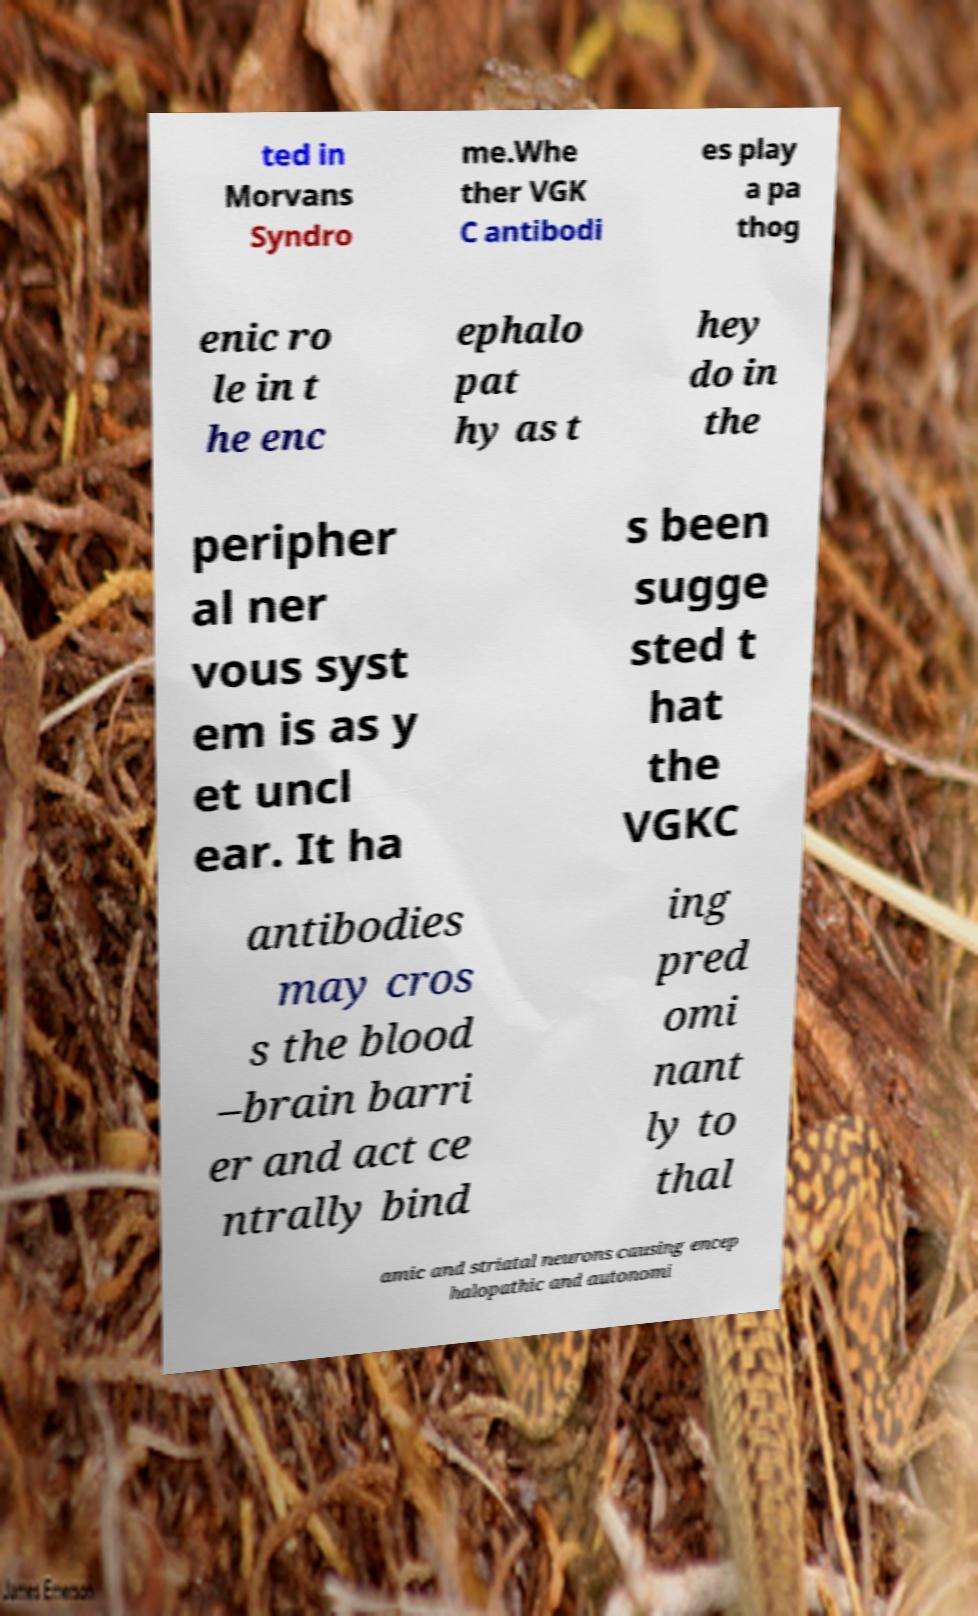Please read and relay the text visible in this image. What does it say? ted in Morvans Syndro me.Whe ther VGK C antibodi es play a pa thog enic ro le in t he enc ephalo pat hy as t hey do in the peripher al ner vous syst em is as y et uncl ear. It ha s been sugge sted t hat the VGKC antibodies may cros s the blood –brain barri er and act ce ntrally bind ing pred omi nant ly to thal amic and striatal neurons causing encep halopathic and autonomi 